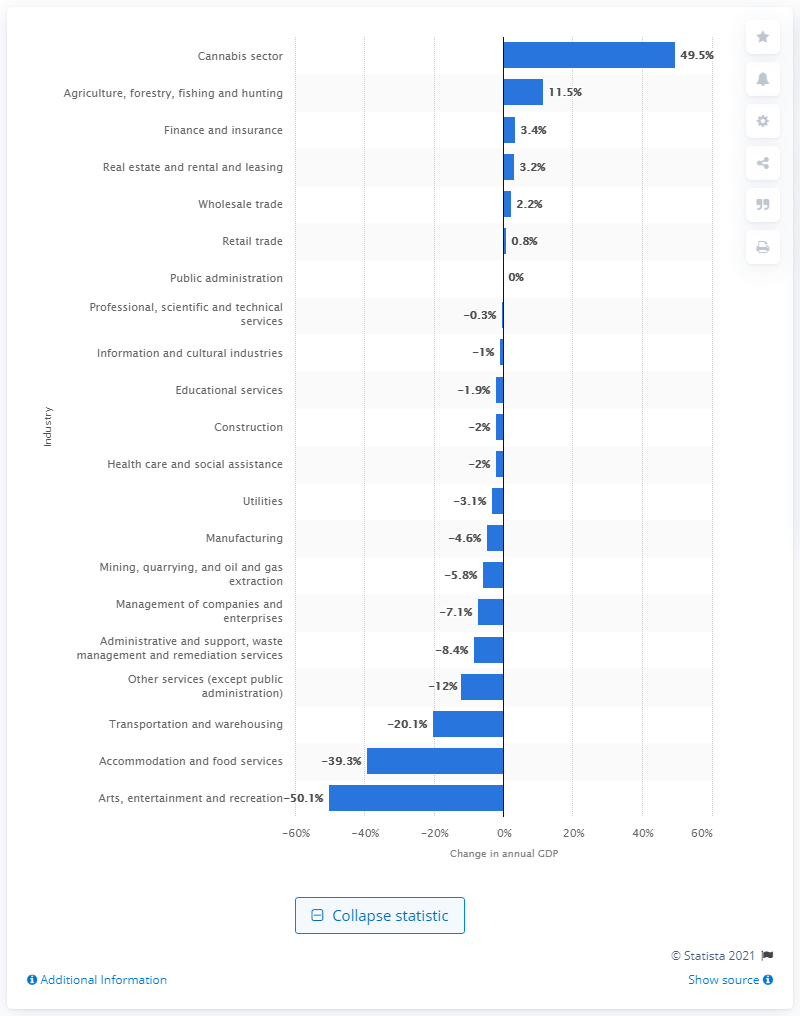Draw attention to some important aspects in this diagram. During the period between December 2019 and December 2020, there was a significant change in the cannabis industry, with 11.5% of the industry undergoing transformation. 